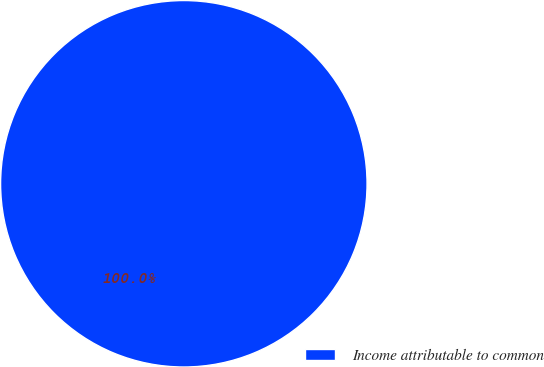Convert chart to OTSL. <chart><loc_0><loc_0><loc_500><loc_500><pie_chart><fcel>Income attributable to common<nl><fcel>100.0%<nl></chart> 